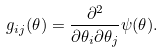Convert formula to latex. <formula><loc_0><loc_0><loc_500><loc_500>g _ { i j } ( \theta ) = \frac { \partial ^ { 2 } } { \partial \theta _ { i } \partial \theta _ { j } } \psi ( \theta ) .</formula> 